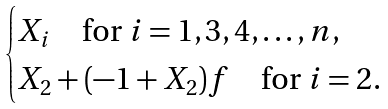<formula> <loc_0><loc_0><loc_500><loc_500>\begin{cases} X _ { i } \quad \text {for} \ i = 1 , 3 , 4 , \dots , n , \\ X _ { 2 } + ( - 1 + X _ { 2 } ) f \quad \text {for} \ i = 2 . \end{cases}</formula> 